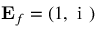Convert formula to latex. <formula><loc_0><loc_0><loc_500><loc_500>{ E _ { f } } = ( 1 , { i } )</formula> 